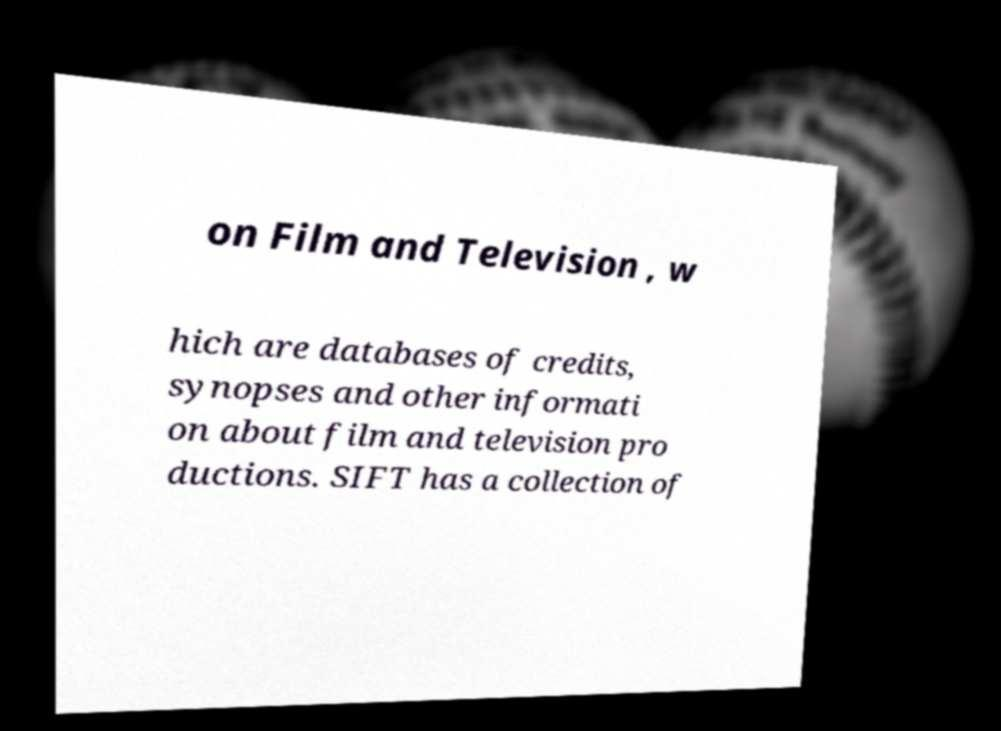Please identify and transcribe the text found in this image. on Film and Television , w hich are databases of credits, synopses and other informati on about film and television pro ductions. SIFT has a collection of 